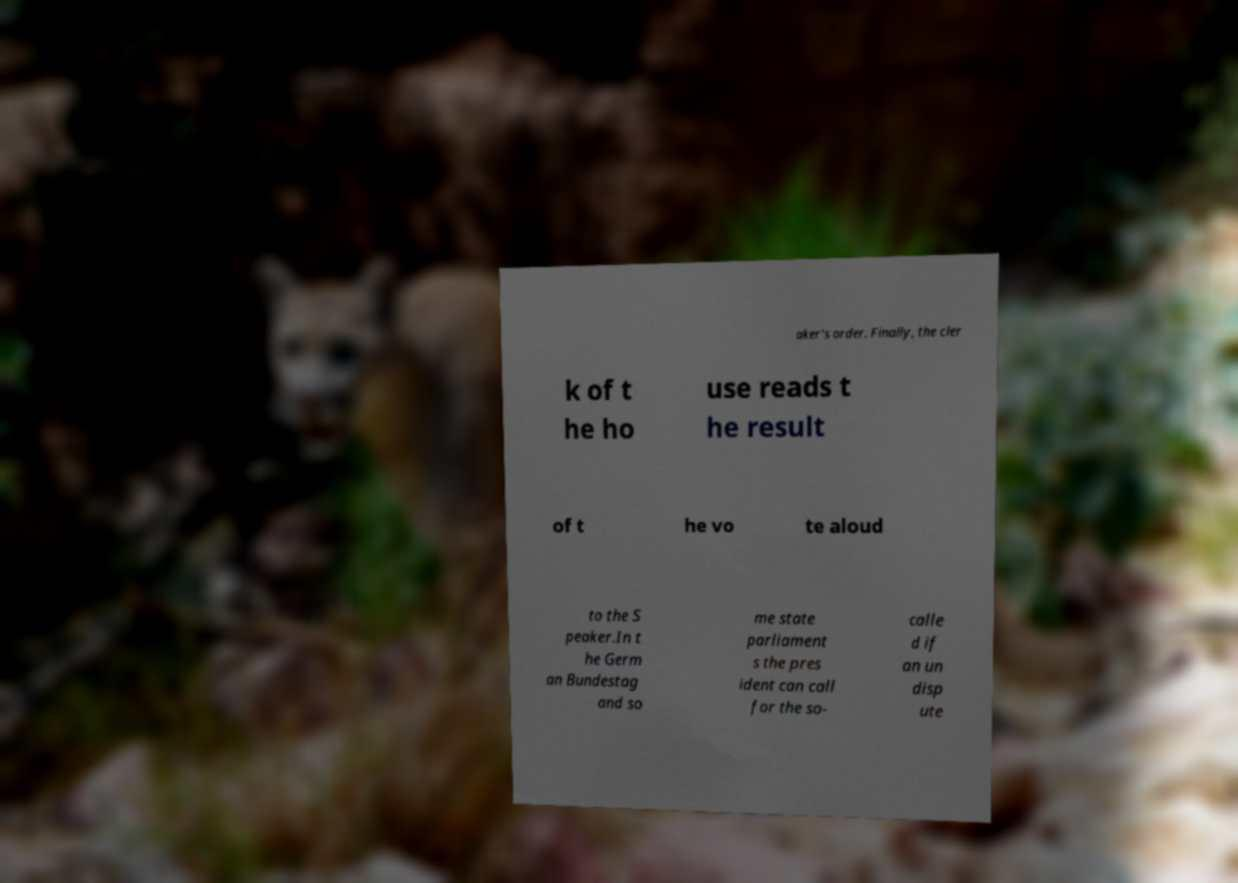Can you read and provide the text displayed in the image?This photo seems to have some interesting text. Can you extract and type it out for me? aker's order. Finally, the cler k of t he ho use reads t he result of t he vo te aloud to the S peaker.In t he Germ an Bundestag and so me state parliament s the pres ident can call for the so- calle d if an un disp ute 